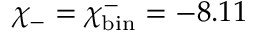Convert formula to latex. <formula><loc_0><loc_0><loc_500><loc_500>\chi _ { - } = \chi _ { b i n } ^ { - } = - 8 . 1 1</formula> 